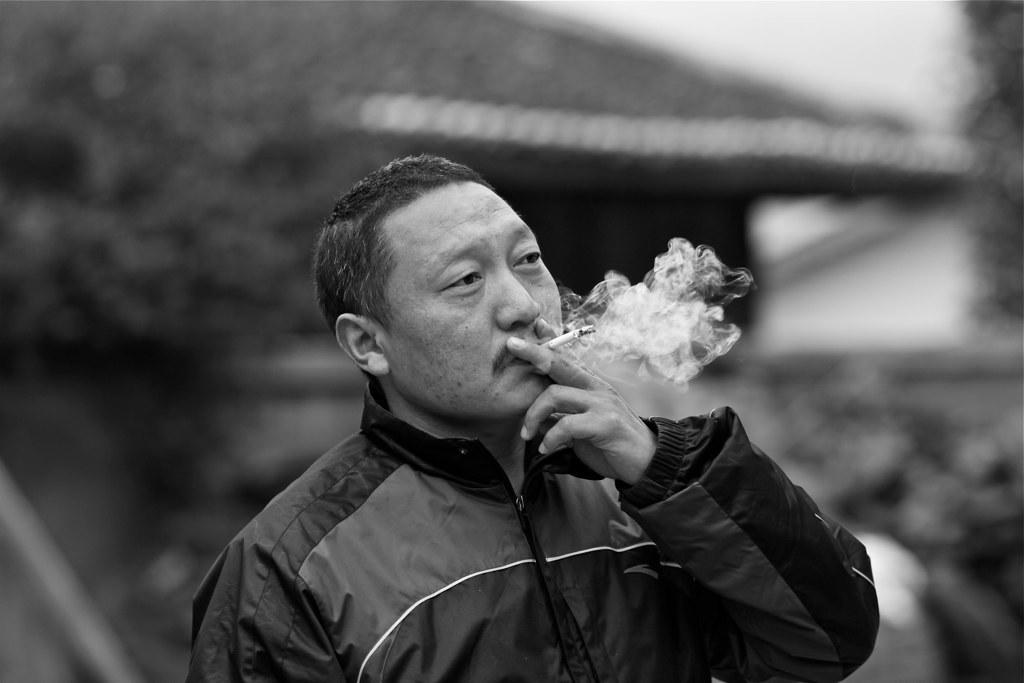What is the main subject of the image? There is a man in the image. What is the man doing in the image? The man is standing and smoking a cigarette. What is the man wearing in the image? The man is wearing a jacket. Can you describe the objects behind the man in the image? The nature of the objects behind the man is not clearly visible. What type of meal is the man preparing for the hen in the image? There is no hen or meal preparation visible in the image. What type of cable can be seen connecting the man to the objects behind him in the image? There is no cable visible connecting the man to the objects behind him in the image. 